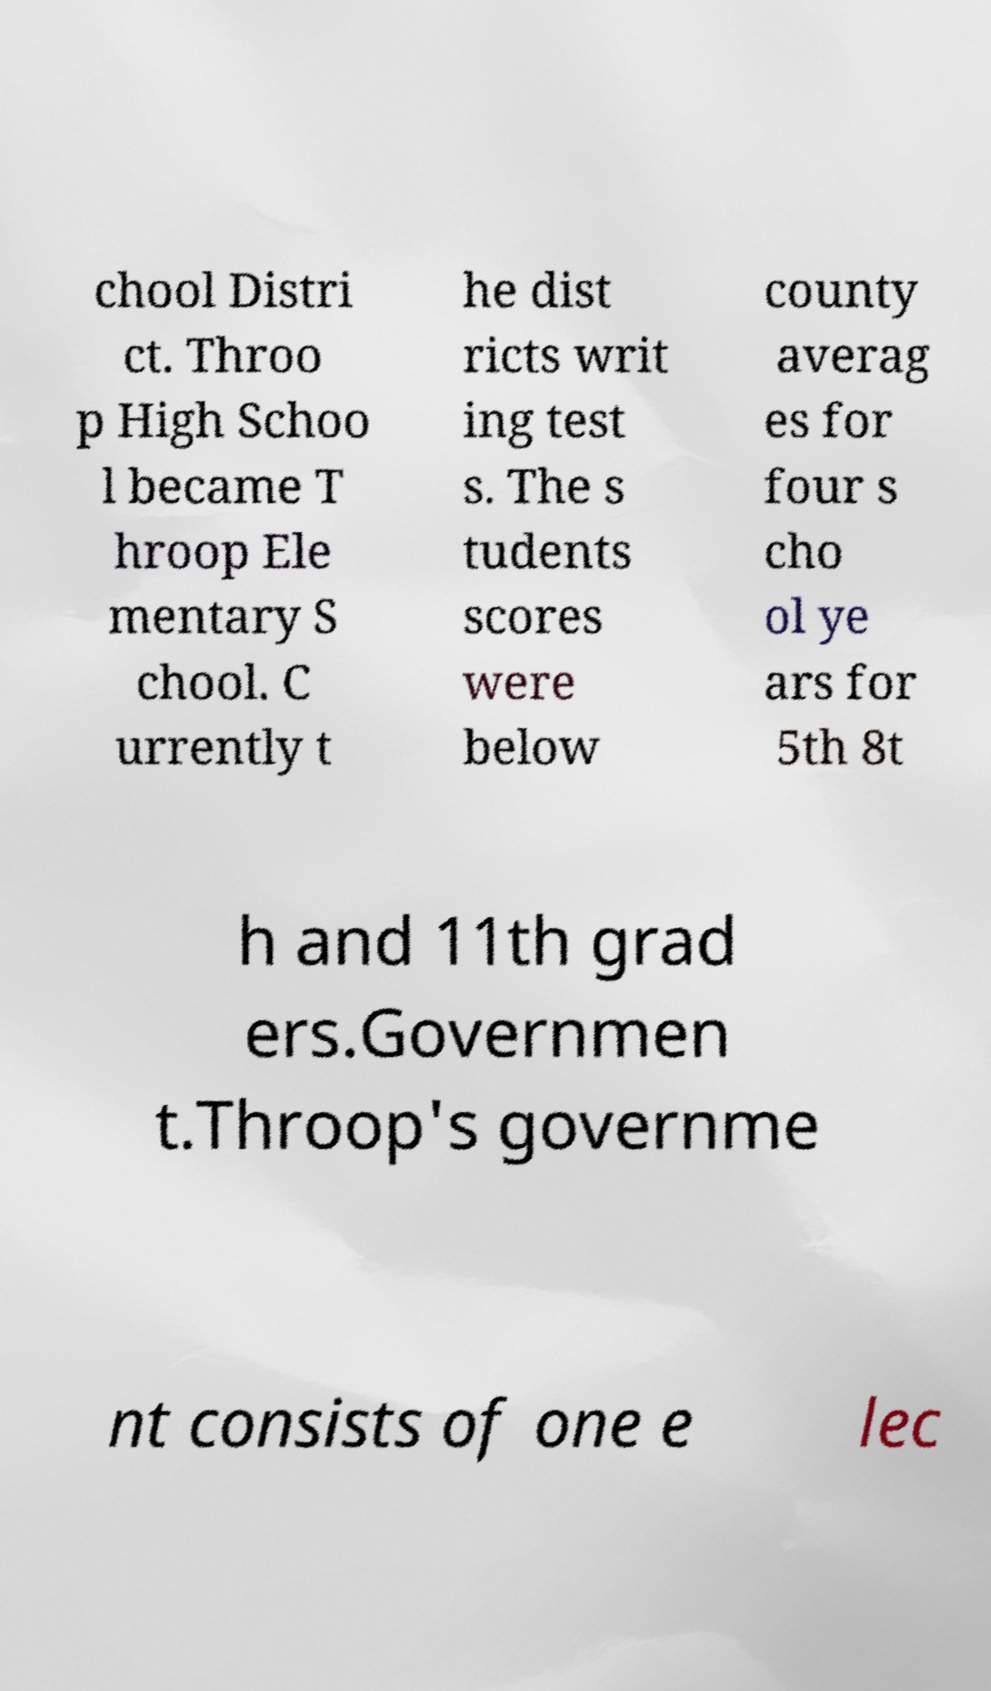What messages or text are displayed in this image? I need them in a readable, typed format. chool Distri ct. Throo p High Schoo l became T hroop Ele mentary S chool. C urrently t he dist ricts writ ing test s. The s tudents scores were below county averag es for four s cho ol ye ars for 5th 8t h and 11th grad ers.Governmen t.Throop's governme nt consists of one e lec 